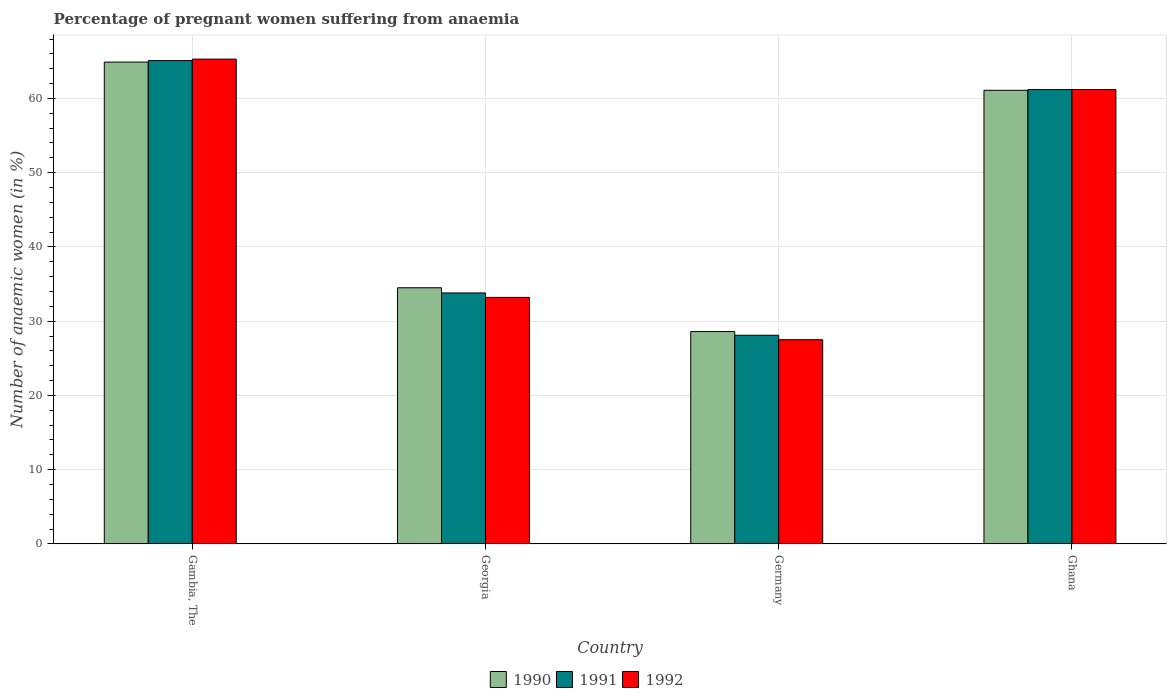How many different coloured bars are there?
Your answer should be very brief. 3. Are the number of bars per tick equal to the number of legend labels?
Ensure brevity in your answer.  Yes. Are the number of bars on each tick of the X-axis equal?
Keep it short and to the point. Yes. How many bars are there on the 3rd tick from the left?
Offer a very short reply. 3. How many bars are there on the 4th tick from the right?
Make the answer very short. 3. What is the label of the 4th group of bars from the left?
Make the answer very short. Ghana. What is the number of anaemic women in 1992 in Ghana?
Keep it short and to the point. 61.2. Across all countries, what is the maximum number of anaemic women in 1990?
Your answer should be very brief. 64.9. Across all countries, what is the minimum number of anaemic women in 1990?
Provide a short and direct response. 28.6. In which country was the number of anaemic women in 1991 maximum?
Give a very brief answer. Gambia, The. In which country was the number of anaemic women in 1992 minimum?
Your answer should be compact. Germany. What is the total number of anaemic women in 1992 in the graph?
Ensure brevity in your answer.  187.2. What is the difference between the number of anaemic women in 1991 in Gambia, The and that in Georgia?
Offer a terse response. 31.3. What is the difference between the number of anaemic women in 1991 in Ghana and the number of anaemic women in 1990 in Germany?
Keep it short and to the point. 32.6. What is the average number of anaemic women in 1991 per country?
Provide a short and direct response. 47.05. What is the difference between the number of anaemic women of/in 1990 and number of anaemic women of/in 1992 in Germany?
Ensure brevity in your answer.  1.1. In how many countries, is the number of anaemic women in 1992 greater than 36 %?
Ensure brevity in your answer.  2. What is the ratio of the number of anaemic women in 1992 in Gambia, The to that in Ghana?
Keep it short and to the point. 1.07. Is the number of anaemic women in 1990 in Gambia, The less than that in Ghana?
Your response must be concise. No. Is the difference between the number of anaemic women in 1990 in Georgia and Germany greater than the difference between the number of anaemic women in 1992 in Georgia and Germany?
Make the answer very short. Yes. What is the difference between the highest and the second highest number of anaemic women in 1991?
Make the answer very short. 3.9. What is the difference between the highest and the lowest number of anaemic women in 1991?
Provide a succinct answer. 37. Is it the case that in every country, the sum of the number of anaemic women in 1990 and number of anaemic women in 1992 is greater than the number of anaemic women in 1991?
Your response must be concise. Yes. How many bars are there?
Offer a very short reply. 12. Are all the bars in the graph horizontal?
Keep it short and to the point. No. Are the values on the major ticks of Y-axis written in scientific E-notation?
Your answer should be compact. No. Does the graph contain any zero values?
Make the answer very short. No. Does the graph contain grids?
Offer a very short reply. Yes. How are the legend labels stacked?
Provide a short and direct response. Horizontal. What is the title of the graph?
Make the answer very short. Percentage of pregnant women suffering from anaemia. What is the label or title of the Y-axis?
Your answer should be compact. Number of anaemic women (in %). What is the Number of anaemic women (in %) of 1990 in Gambia, The?
Offer a terse response. 64.9. What is the Number of anaemic women (in %) of 1991 in Gambia, The?
Your answer should be very brief. 65.1. What is the Number of anaemic women (in %) in 1992 in Gambia, The?
Offer a very short reply. 65.3. What is the Number of anaemic women (in %) in 1990 in Georgia?
Your answer should be very brief. 34.5. What is the Number of anaemic women (in %) of 1991 in Georgia?
Ensure brevity in your answer.  33.8. What is the Number of anaemic women (in %) in 1992 in Georgia?
Your answer should be very brief. 33.2. What is the Number of anaemic women (in %) of 1990 in Germany?
Offer a terse response. 28.6. What is the Number of anaemic women (in %) of 1991 in Germany?
Your answer should be compact. 28.1. What is the Number of anaemic women (in %) in 1992 in Germany?
Give a very brief answer. 27.5. What is the Number of anaemic women (in %) in 1990 in Ghana?
Your response must be concise. 61.1. What is the Number of anaemic women (in %) of 1991 in Ghana?
Make the answer very short. 61.2. What is the Number of anaemic women (in %) of 1992 in Ghana?
Ensure brevity in your answer.  61.2. Across all countries, what is the maximum Number of anaemic women (in %) in 1990?
Your answer should be very brief. 64.9. Across all countries, what is the maximum Number of anaemic women (in %) of 1991?
Provide a short and direct response. 65.1. Across all countries, what is the maximum Number of anaemic women (in %) of 1992?
Give a very brief answer. 65.3. Across all countries, what is the minimum Number of anaemic women (in %) of 1990?
Offer a terse response. 28.6. Across all countries, what is the minimum Number of anaemic women (in %) of 1991?
Offer a terse response. 28.1. Across all countries, what is the minimum Number of anaemic women (in %) in 1992?
Your response must be concise. 27.5. What is the total Number of anaemic women (in %) in 1990 in the graph?
Your answer should be compact. 189.1. What is the total Number of anaemic women (in %) of 1991 in the graph?
Make the answer very short. 188.2. What is the total Number of anaemic women (in %) of 1992 in the graph?
Ensure brevity in your answer.  187.2. What is the difference between the Number of anaemic women (in %) of 1990 in Gambia, The and that in Georgia?
Your response must be concise. 30.4. What is the difference between the Number of anaemic women (in %) in 1991 in Gambia, The and that in Georgia?
Your answer should be compact. 31.3. What is the difference between the Number of anaemic women (in %) in 1992 in Gambia, The and that in Georgia?
Your response must be concise. 32.1. What is the difference between the Number of anaemic women (in %) of 1990 in Gambia, The and that in Germany?
Make the answer very short. 36.3. What is the difference between the Number of anaemic women (in %) of 1991 in Gambia, The and that in Germany?
Provide a succinct answer. 37. What is the difference between the Number of anaemic women (in %) of 1992 in Gambia, The and that in Germany?
Ensure brevity in your answer.  37.8. What is the difference between the Number of anaemic women (in %) of 1992 in Georgia and that in Germany?
Your answer should be compact. 5.7. What is the difference between the Number of anaemic women (in %) of 1990 in Georgia and that in Ghana?
Your response must be concise. -26.6. What is the difference between the Number of anaemic women (in %) of 1991 in Georgia and that in Ghana?
Offer a terse response. -27.4. What is the difference between the Number of anaemic women (in %) in 1990 in Germany and that in Ghana?
Make the answer very short. -32.5. What is the difference between the Number of anaemic women (in %) in 1991 in Germany and that in Ghana?
Your response must be concise. -33.1. What is the difference between the Number of anaemic women (in %) of 1992 in Germany and that in Ghana?
Your answer should be compact. -33.7. What is the difference between the Number of anaemic women (in %) in 1990 in Gambia, The and the Number of anaemic women (in %) in 1991 in Georgia?
Your answer should be very brief. 31.1. What is the difference between the Number of anaemic women (in %) of 1990 in Gambia, The and the Number of anaemic women (in %) of 1992 in Georgia?
Your answer should be compact. 31.7. What is the difference between the Number of anaemic women (in %) in 1991 in Gambia, The and the Number of anaemic women (in %) in 1992 in Georgia?
Give a very brief answer. 31.9. What is the difference between the Number of anaemic women (in %) of 1990 in Gambia, The and the Number of anaemic women (in %) of 1991 in Germany?
Your response must be concise. 36.8. What is the difference between the Number of anaemic women (in %) in 1990 in Gambia, The and the Number of anaemic women (in %) in 1992 in Germany?
Offer a very short reply. 37.4. What is the difference between the Number of anaemic women (in %) of 1991 in Gambia, The and the Number of anaemic women (in %) of 1992 in Germany?
Ensure brevity in your answer.  37.6. What is the difference between the Number of anaemic women (in %) of 1990 in Gambia, The and the Number of anaemic women (in %) of 1991 in Ghana?
Your answer should be very brief. 3.7. What is the difference between the Number of anaemic women (in %) in 1991 in Georgia and the Number of anaemic women (in %) in 1992 in Germany?
Give a very brief answer. 6.3. What is the difference between the Number of anaemic women (in %) in 1990 in Georgia and the Number of anaemic women (in %) in 1991 in Ghana?
Offer a very short reply. -26.7. What is the difference between the Number of anaemic women (in %) in 1990 in Georgia and the Number of anaemic women (in %) in 1992 in Ghana?
Give a very brief answer. -26.7. What is the difference between the Number of anaemic women (in %) of 1991 in Georgia and the Number of anaemic women (in %) of 1992 in Ghana?
Your answer should be compact. -27.4. What is the difference between the Number of anaemic women (in %) of 1990 in Germany and the Number of anaemic women (in %) of 1991 in Ghana?
Offer a terse response. -32.6. What is the difference between the Number of anaemic women (in %) of 1990 in Germany and the Number of anaemic women (in %) of 1992 in Ghana?
Ensure brevity in your answer.  -32.6. What is the difference between the Number of anaemic women (in %) in 1991 in Germany and the Number of anaemic women (in %) in 1992 in Ghana?
Provide a short and direct response. -33.1. What is the average Number of anaemic women (in %) in 1990 per country?
Your answer should be very brief. 47.27. What is the average Number of anaemic women (in %) in 1991 per country?
Give a very brief answer. 47.05. What is the average Number of anaemic women (in %) in 1992 per country?
Your answer should be very brief. 46.8. What is the difference between the Number of anaemic women (in %) in 1990 and Number of anaemic women (in %) in 1991 in Gambia, The?
Provide a succinct answer. -0.2. What is the difference between the Number of anaemic women (in %) of 1990 and Number of anaemic women (in %) of 1992 in Gambia, The?
Provide a short and direct response. -0.4. What is the difference between the Number of anaemic women (in %) of 1991 and Number of anaemic women (in %) of 1992 in Gambia, The?
Keep it short and to the point. -0.2. What is the difference between the Number of anaemic women (in %) of 1990 and Number of anaemic women (in %) of 1991 in Georgia?
Your response must be concise. 0.7. What is the difference between the Number of anaemic women (in %) of 1990 and Number of anaemic women (in %) of 1991 in Ghana?
Your response must be concise. -0.1. What is the difference between the Number of anaemic women (in %) of 1990 and Number of anaemic women (in %) of 1992 in Ghana?
Offer a terse response. -0.1. What is the difference between the Number of anaemic women (in %) of 1991 and Number of anaemic women (in %) of 1992 in Ghana?
Provide a short and direct response. 0. What is the ratio of the Number of anaemic women (in %) in 1990 in Gambia, The to that in Georgia?
Offer a terse response. 1.88. What is the ratio of the Number of anaemic women (in %) in 1991 in Gambia, The to that in Georgia?
Provide a succinct answer. 1.93. What is the ratio of the Number of anaemic women (in %) in 1992 in Gambia, The to that in Georgia?
Keep it short and to the point. 1.97. What is the ratio of the Number of anaemic women (in %) of 1990 in Gambia, The to that in Germany?
Make the answer very short. 2.27. What is the ratio of the Number of anaemic women (in %) of 1991 in Gambia, The to that in Germany?
Give a very brief answer. 2.32. What is the ratio of the Number of anaemic women (in %) of 1992 in Gambia, The to that in Germany?
Your response must be concise. 2.37. What is the ratio of the Number of anaemic women (in %) in 1990 in Gambia, The to that in Ghana?
Make the answer very short. 1.06. What is the ratio of the Number of anaemic women (in %) of 1991 in Gambia, The to that in Ghana?
Provide a short and direct response. 1.06. What is the ratio of the Number of anaemic women (in %) of 1992 in Gambia, The to that in Ghana?
Give a very brief answer. 1.07. What is the ratio of the Number of anaemic women (in %) in 1990 in Georgia to that in Germany?
Provide a succinct answer. 1.21. What is the ratio of the Number of anaemic women (in %) in 1991 in Georgia to that in Germany?
Provide a short and direct response. 1.2. What is the ratio of the Number of anaemic women (in %) of 1992 in Georgia to that in Germany?
Provide a short and direct response. 1.21. What is the ratio of the Number of anaemic women (in %) of 1990 in Georgia to that in Ghana?
Keep it short and to the point. 0.56. What is the ratio of the Number of anaemic women (in %) of 1991 in Georgia to that in Ghana?
Offer a terse response. 0.55. What is the ratio of the Number of anaemic women (in %) in 1992 in Georgia to that in Ghana?
Offer a very short reply. 0.54. What is the ratio of the Number of anaemic women (in %) of 1990 in Germany to that in Ghana?
Keep it short and to the point. 0.47. What is the ratio of the Number of anaemic women (in %) in 1991 in Germany to that in Ghana?
Offer a very short reply. 0.46. What is the ratio of the Number of anaemic women (in %) in 1992 in Germany to that in Ghana?
Offer a terse response. 0.45. What is the difference between the highest and the second highest Number of anaemic women (in %) of 1990?
Your answer should be very brief. 3.8. What is the difference between the highest and the second highest Number of anaemic women (in %) of 1992?
Your answer should be compact. 4.1. What is the difference between the highest and the lowest Number of anaemic women (in %) of 1990?
Provide a short and direct response. 36.3. What is the difference between the highest and the lowest Number of anaemic women (in %) of 1992?
Provide a short and direct response. 37.8. 